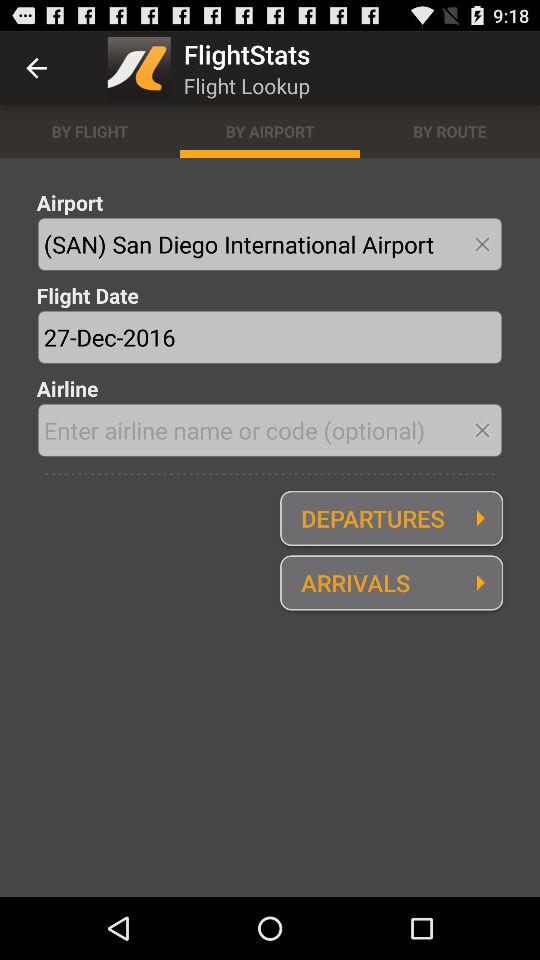How many text inputs are there that are not optional?
Answer the question using a single word or phrase. 2 